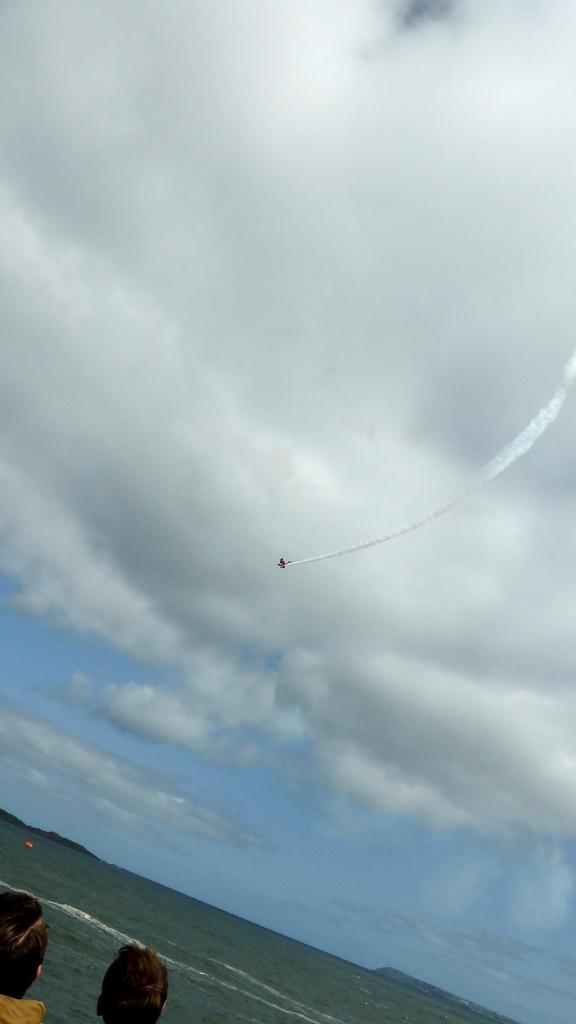Could you give a brief overview of what you see in this image? In the center of the image we can see an aeroplane flying in the sky. At the bottom there are people and we can see water. In the background there is sky. 